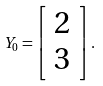<formula> <loc_0><loc_0><loc_500><loc_500>Y _ { 0 } = \left [ \begin{array} { c } 2 \\ 3 \end{array} \right ] .</formula> 